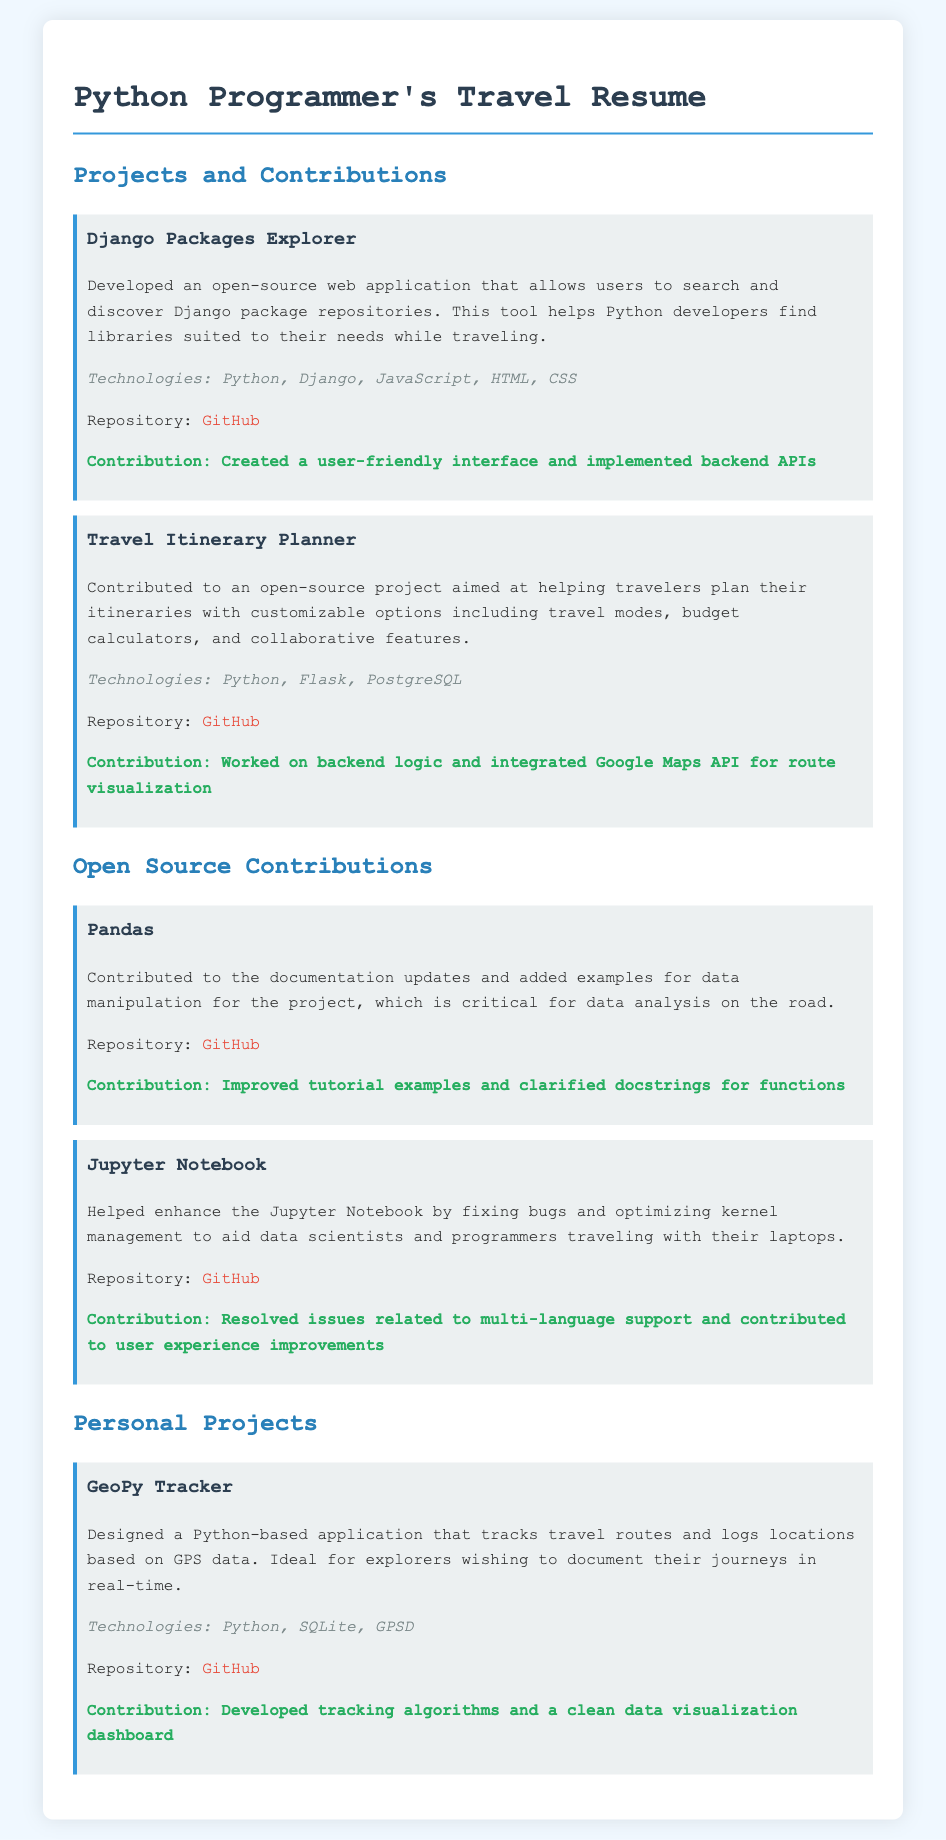What is the title of the first project listed? The title of the first project is mentioned as "Django Packages Explorer."
Answer: Django Packages Explorer What are the technologies used in the Travel Itinerary Planner? The technologies used in the Travel Itinerary Planner project include Python, Flask, and PostgreSQL.
Answer: Python, Flask, PostgreSQL What contribution was made to the Pandas project? The document states that the contribution involved improving tutorial examples and clarifying docstrings for functions.
Answer: Improved tutorial examples and clarified docstrings for functions How many personal projects are listed in the document? The document lists one personal project titled "GeoPy Tracker."
Answer: One What is the contribution made to the Jupyter Notebook project? The contribution to the Jupyter Notebook project is resolving issues related to multi-language support and improving user experience.
Answer: Resolved issues related to multi-language support and contributed to user experience improvements Which open-source project helps users discover Django packages? The project that helps users discover Django packages is "Django Packages Explorer."
Answer: Django Packages Explorer What is the repository link for the GeoPy Tracker? The repository link for the GeoPy Tracker is provided in the document.
Answer: https://github.com/yourusername/geopy-tracker Which application is designed for tracking travel routes based on GPS data? The application designed for tracking travel routes based on GPS data is named "GeoPy Tracker."
Answer: GeoPy Tracker 